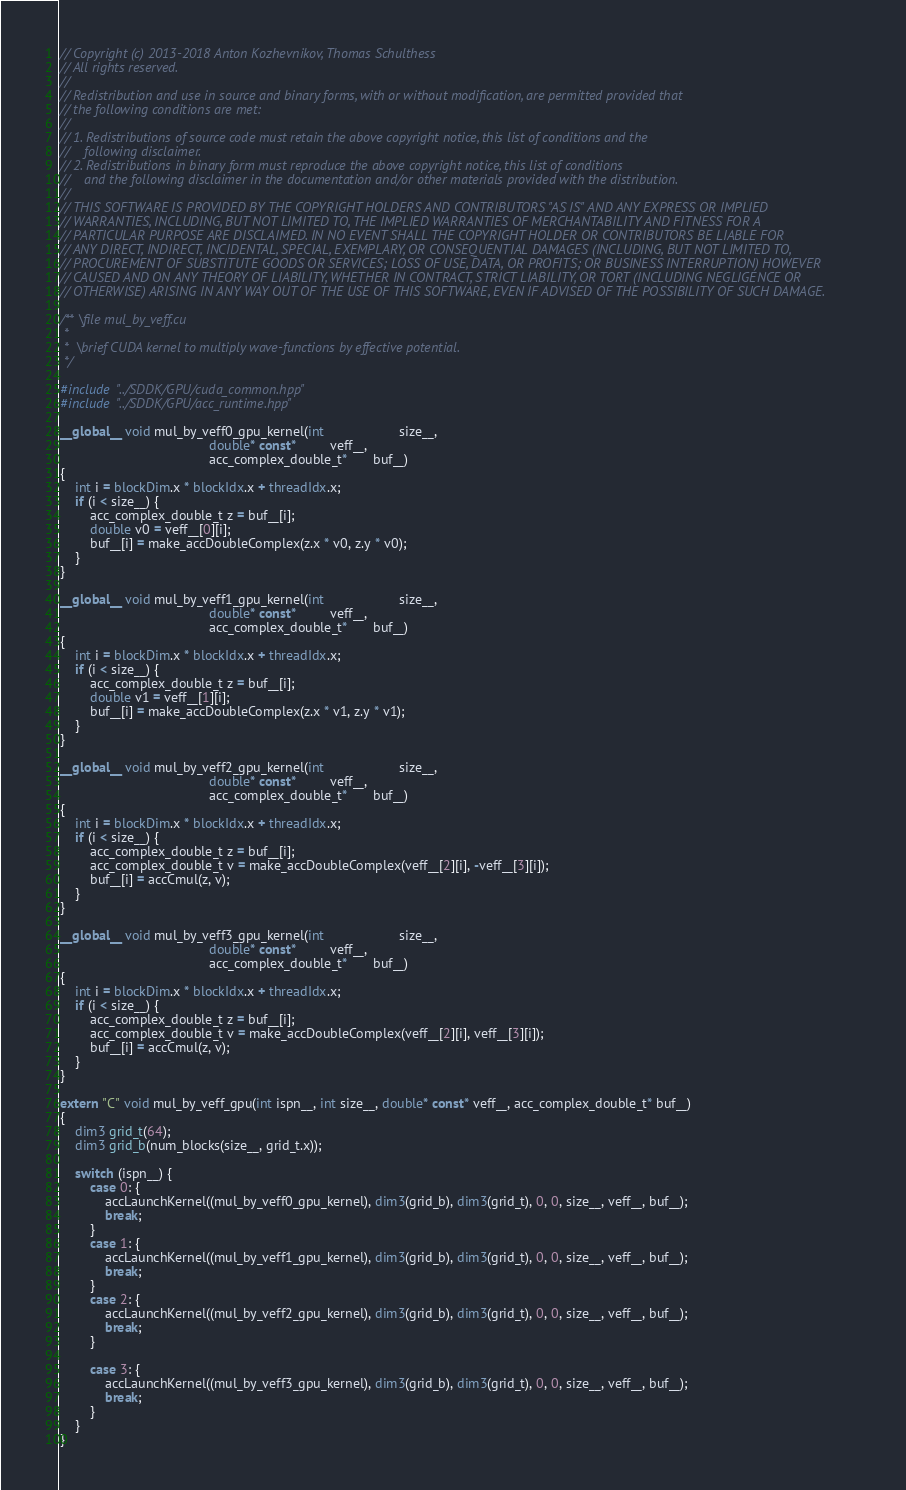Convert code to text. <code><loc_0><loc_0><loc_500><loc_500><_Cuda_>// Copyright (c) 2013-2018 Anton Kozhevnikov, Thomas Schulthess
// All rights reserved.
//
// Redistribution and use in source and binary forms, with or without modification, are permitted provided that
// the following conditions are met:
//
// 1. Redistributions of source code must retain the above copyright notice, this list of conditions and the
//    following disclaimer.
// 2. Redistributions in binary form must reproduce the above copyright notice, this list of conditions
//    and the following disclaimer in the documentation and/or other materials provided with the distribution.
//
// THIS SOFTWARE IS PROVIDED BY THE COPYRIGHT HOLDERS AND CONTRIBUTORS "AS IS" AND ANY EXPRESS OR IMPLIED
// WARRANTIES, INCLUDING, BUT NOT LIMITED TO, THE IMPLIED WARRANTIES OF MERCHANTABILITY AND FITNESS FOR A
// PARTICULAR PURPOSE ARE DISCLAIMED. IN NO EVENT SHALL THE COPYRIGHT HOLDER OR CONTRIBUTORS BE LIABLE FOR
// ANY DIRECT, INDIRECT, INCIDENTAL, SPECIAL, EXEMPLARY, OR CONSEQUENTIAL DAMAGES (INCLUDING, BUT NOT LIMITED TO,
// PROCUREMENT OF SUBSTITUTE GOODS OR SERVICES; LOSS OF USE, DATA, OR PROFITS; OR BUSINESS INTERRUPTION) HOWEVER
// CAUSED AND ON ANY THEORY OF LIABILITY, WHETHER IN CONTRACT, STRICT LIABILITY, OR TORT (INCLUDING NEGLIGENCE OR
// OTHERWISE) ARISING IN ANY WAY OUT OF THE USE OF THIS SOFTWARE, EVEN IF ADVISED OF THE POSSIBILITY OF SUCH DAMAGE.

/** \file mul_by_veff.cu
 *
 *  \brief CUDA kernel to multiply wave-functions by effective potential.
 */

#include "../SDDK/GPU/cuda_common.hpp"
#include "../SDDK/GPU/acc_runtime.hpp"

__global__ void mul_by_veff0_gpu_kernel(int                    size__,
                                        double* const*         veff__,
                                        acc_complex_double_t*       buf__)
{
    int i = blockDim.x * blockIdx.x + threadIdx.x;
    if (i < size__) {
        acc_complex_double_t z = buf__[i];
        double v0 = veff__[0][i];
        buf__[i] = make_accDoubleComplex(z.x * v0, z.y * v0);
    }
}

__global__ void mul_by_veff1_gpu_kernel(int                    size__,
                                        double* const*         veff__,
                                        acc_complex_double_t*       buf__)
{
    int i = blockDim.x * blockIdx.x + threadIdx.x;
    if (i < size__) {
        acc_complex_double_t z = buf__[i];
        double v1 = veff__[1][i];
        buf__[i] = make_accDoubleComplex(z.x * v1, z.y * v1);
    }
}

__global__ void mul_by_veff2_gpu_kernel(int                    size__,
                                        double* const*         veff__,
                                        acc_complex_double_t*       buf__)
{
    int i = blockDim.x * blockIdx.x + threadIdx.x;
    if (i < size__) {
        acc_complex_double_t z = buf__[i];
        acc_complex_double_t v = make_accDoubleComplex(veff__[2][i], -veff__[3][i]);  
        buf__[i] = accCmul(z, v);
    }
}

__global__ void mul_by_veff3_gpu_kernel(int                    size__,
                                        double* const*         veff__,
                                        acc_complex_double_t*       buf__)
{
    int i = blockDim.x * blockIdx.x + threadIdx.x;
    if (i < size__) {
        acc_complex_double_t z = buf__[i];
        acc_complex_double_t v = make_accDoubleComplex(veff__[2][i], veff__[3][i]);
        buf__[i] = accCmul(z, v);
    }
}

extern "C" void mul_by_veff_gpu(int ispn__, int size__, double* const* veff__, acc_complex_double_t* buf__)
{
    dim3 grid_t(64);
    dim3 grid_b(num_blocks(size__, grid_t.x));

    switch (ispn__) {
        case 0: {
            accLaunchKernel((mul_by_veff0_gpu_kernel), dim3(grid_b), dim3(grid_t), 0, 0, size__, veff__, buf__);
            break;
        }
        case 1: {
            accLaunchKernel((mul_by_veff1_gpu_kernel), dim3(grid_b), dim3(grid_t), 0, 0, size__, veff__, buf__);
            break;
        }
        case 2: {
            accLaunchKernel((mul_by_veff2_gpu_kernel), dim3(grid_b), dim3(grid_t), 0, 0, size__, veff__, buf__);
            break;
        }

        case 3: {
            accLaunchKernel((mul_by_veff3_gpu_kernel), dim3(grid_b), dim3(grid_t), 0, 0, size__, veff__, buf__);
            break;
        }
    }
}
</code> 